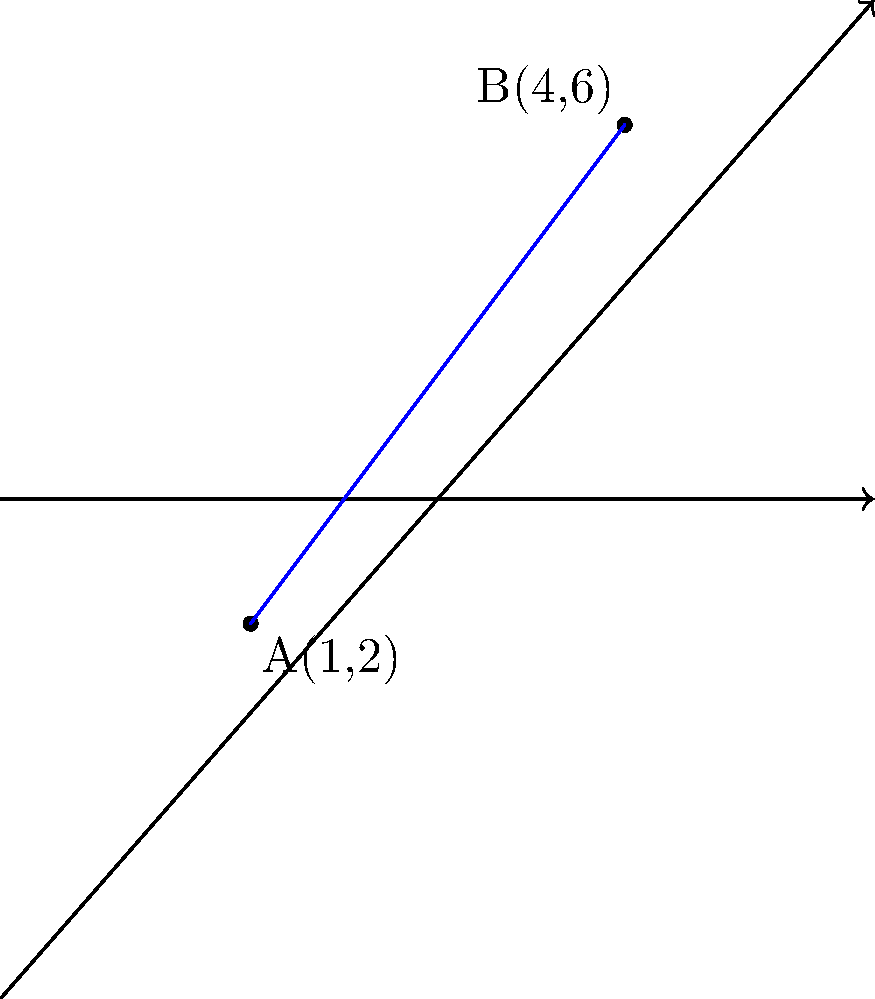In the context of analyzing voting patterns across different regions in Nigeria and the UK, consider two data points on a coordinate plane representing voter turnout percentages. Point A(1,2) represents a local constituency in Lagos, while point B(4,6) represents a borough in London. Calculate the distance between these two points to quantify the difference in voter engagement between these areas. To find the distance between two points on a coordinate plane, we can use the distance formula, which is derived from the Pythagorean theorem:

$$d = \sqrt{(x_2 - x_1)^2 + (y_2 - y_1)^2}$$

Where $(x_1, y_1)$ are the coordinates of the first point and $(x_2, y_2)$ are the coordinates of the second point.

Given:
Point A: $(1, 2)$
Point B: $(4, 6)$

Let's substitute these values into the formula:

$$\begin{align*}
d &= \sqrt{(x_2 - x_1)^2 + (y_2 - y_1)^2} \\
&= \sqrt{(4 - 1)^2 + (6 - 2)^2} \\
&= \sqrt{3^2 + 4^2} \\
&= \sqrt{9 + 16} \\
&= \sqrt{25} \\
&= 5
\end{align*}$$

Therefore, the distance between points A and B is 5 units.

This result quantifies the difference in voter engagement between the local constituency in Lagos and the borough in London, providing a numerical measure for comparative political analysis.
Answer: 5 units 